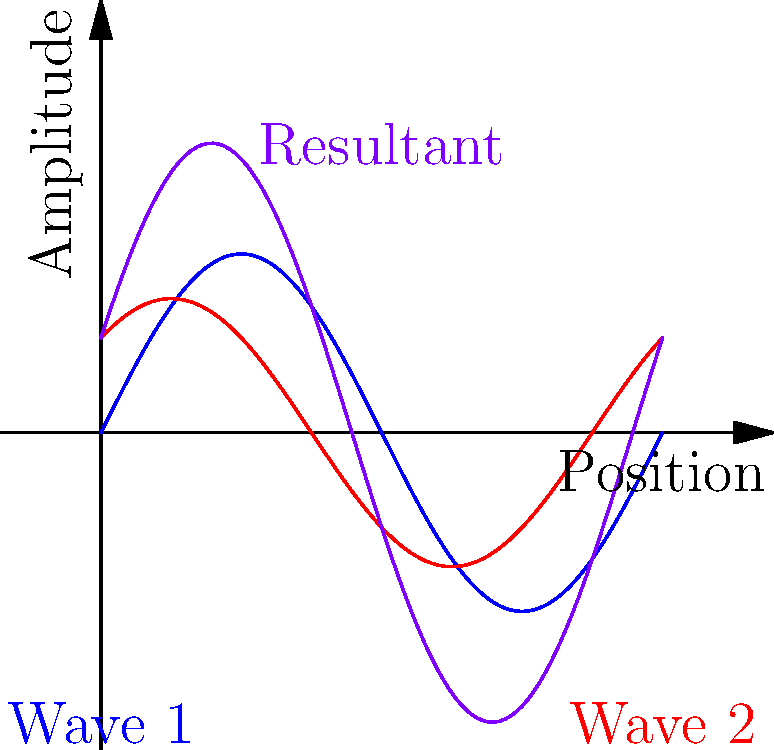During a performance at the Philharmonie de Paris, you notice an interesting sound wave interference pattern. The graph shows two sound waves (blue and red) from different instruments and their resultant wave (purple). What type of interference is occurring at the point where the resultant wave has the highest amplitude? To determine the type of interference, we need to analyze the graph:

1. Observe the two original waves (blue and red):
   - They have slightly different amplitudes and a phase difference.

2. Look at the resultant wave (purple):
   - It has a larger amplitude than either of the original waves.

3. Identify the point of highest amplitude on the resultant wave:
   - This occurs where both original waves have positive amplitudes and are close to their peaks.

4. Compare the original waves at this point:
   - Both waves are contributing positively to the resultant wave.

5. Understand interference types:
   - Constructive interference occurs when waves combine to create a larger amplitude.
   - Destructive interference occurs when waves combine to create a smaller amplitude or cancel out.

6. Conclusion:
   - Since the resultant wave has a higher amplitude than either original wave, this is constructive interference.
Answer: Constructive interference 